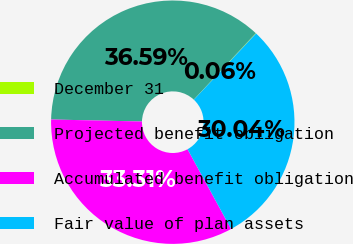Convert chart to OTSL. <chart><loc_0><loc_0><loc_500><loc_500><pie_chart><fcel>December 31<fcel>Projected benefit obligation<fcel>Accumulated benefit obligation<fcel>Fair value of plan assets<nl><fcel>0.06%<fcel>36.59%<fcel>33.31%<fcel>30.04%<nl></chart> 